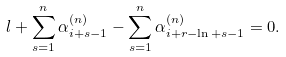<formula> <loc_0><loc_0><loc_500><loc_500>l + \sum _ { s = 1 } ^ { n } \alpha _ { i + s - 1 } ^ { ( n ) } - \sum _ { s = 1 } ^ { n } \alpha _ { i + r - \ln + s - 1 } ^ { ( n ) } = 0 .</formula> 